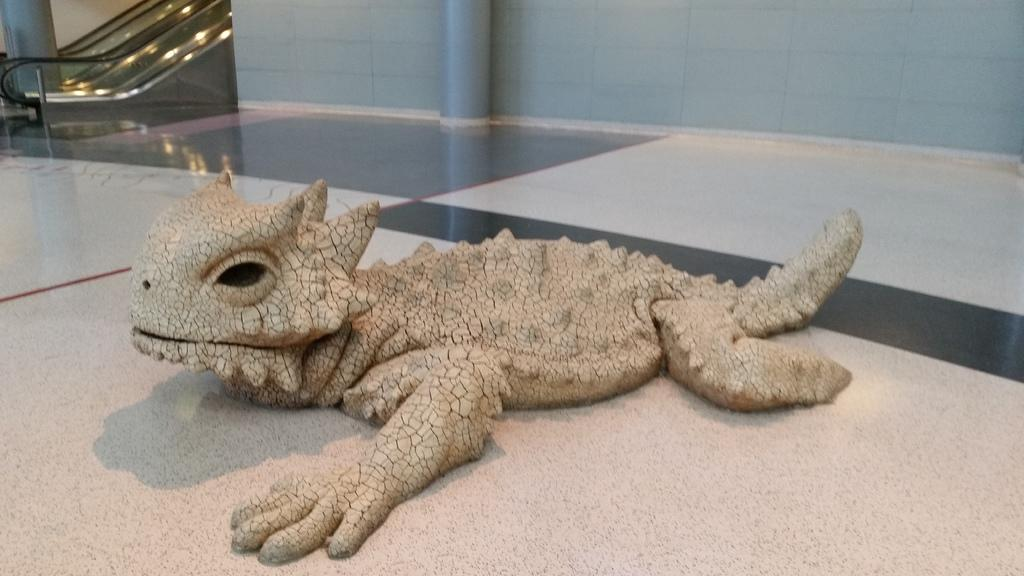What type of toy is on the surface in the image? There is a toy reptile on the surface in the image. What can be seen in the background of the image? There is a wall visible in the image. What architectural feature is present in the image? There is a pillar in the image. What type of transportation is depicted in the image? There is an escalator in the image. What type of pancake is being served on the escalator in the image? There is no pancake present in the image, and the escalator is not serving any food. 